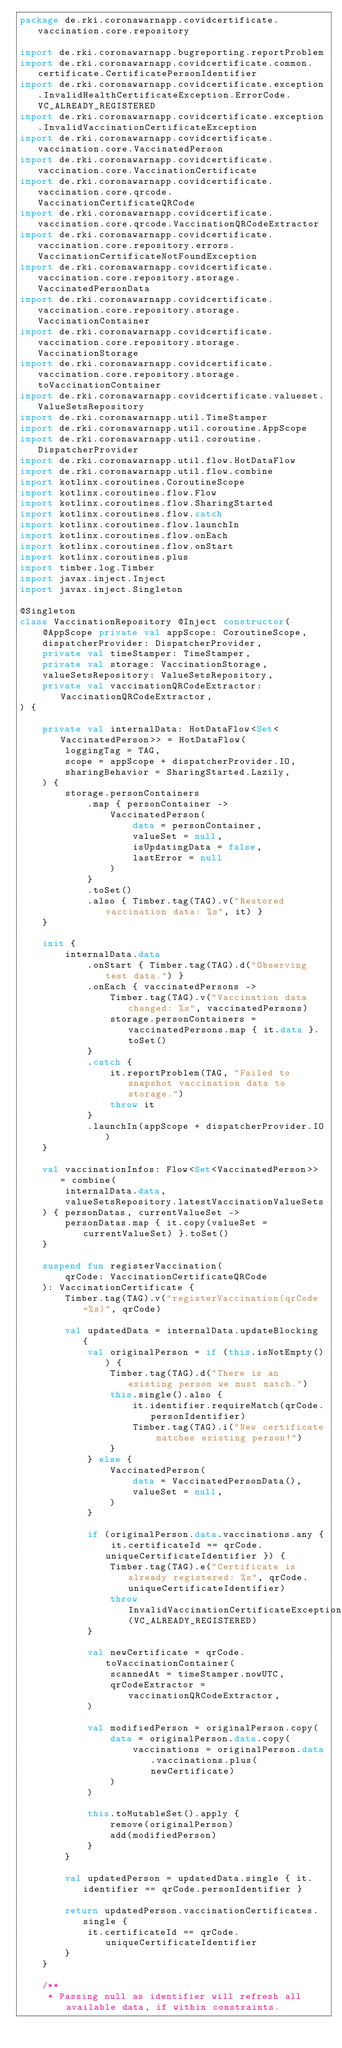Convert code to text. <code><loc_0><loc_0><loc_500><loc_500><_Kotlin_>package de.rki.coronawarnapp.covidcertificate.vaccination.core.repository

import de.rki.coronawarnapp.bugreporting.reportProblem
import de.rki.coronawarnapp.covidcertificate.common.certificate.CertificatePersonIdentifier
import de.rki.coronawarnapp.covidcertificate.exception.InvalidHealthCertificateException.ErrorCode.VC_ALREADY_REGISTERED
import de.rki.coronawarnapp.covidcertificate.exception.InvalidVaccinationCertificateException
import de.rki.coronawarnapp.covidcertificate.vaccination.core.VaccinatedPerson
import de.rki.coronawarnapp.covidcertificate.vaccination.core.VaccinationCertificate
import de.rki.coronawarnapp.covidcertificate.vaccination.core.qrcode.VaccinationCertificateQRCode
import de.rki.coronawarnapp.covidcertificate.vaccination.core.qrcode.VaccinationQRCodeExtractor
import de.rki.coronawarnapp.covidcertificate.vaccination.core.repository.errors.VaccinationCertificateNotFoundException
import de.rki.coronawarnapp.covidcertificate.vaccination.core.repository.storage.VaccinatedPersonData
import de.rki.coronawarnapp.covidcertificate.vaccination.core.repository.storage.VaccinationContainer
import de.rki.coronawarnapp.covidcertificate.vaccination.core.repository.storage.VaccinationStorage
import de.rki.coronawarnapp.covidcertificate.vaccination.core.repository.storage.toVaccinationContainer
import de.rki.coronawarnapp.covidcertificate.valueset.ValueSetsRepository
import de.rki.coronawarnapp.util.TimeStamper
import de.rki.coronawarnapp.util.coroutine.AppScope
import de.rki.coronawarnapp.util.coroutine.DispatcherProvider
import de.rki.coronawarnapp.util.flow.HotDataFlow
import de.rki.coronawarnapp.util.flow.combine
import kotlinx.coroutines.CoroutineScope
import kotlinx.coroutines.flow.Flow
import kotlinx.coroutines.flow.SharingStarted
import kotlinx.coroutines.flow.catch
import kotlinx.coroutines.flow.launchIn
import kotlinx.coroutines.flow.onEach
import kotlinx.coroutines.flow.onStart
import kotlinx.coroutines.plus
import timber.log.Timber
import javax.inject.Inject
import javax.inject.Singleton

@Singleton
class VaccinationRepository @Inject constructor(
    @AppScope private val appScope: CoroutineScope,
    dispatcherProvider: DispatcherProvider,
    private val timeStamper: TimeStamper,
    private val storage: VaccinationStorage,
    valueSetsRepository: ValueSetsRepository,
    private val vaccinationQRCodeExtractor: VaccinationQRCodeExtractor,
) {

    private val internalData: HotDataFlow<Set<VaccinatedPerson>> = HotDataFlow(
        loggingTag = TAG,
        scope = appScope + dispatcherProvider.IO,
        sharingBehavior = SharingStarted.Lazily,
    ) {
        storage.personContainers
            .map { personContainer ->
                VaccinatedPerson(
                    data = personContainer,
                    valueSet = null,
                    isUpdatingData = false,
                    lastError = null
                )
            }
            .toSet()
            .also { Timber.tag(TAG).v("Restored vaccination data: %s", it) }
    }

    init {
        internalData.data
            .onStart { Timber.tag(TAG).d("Observing test data.") }
            .onEach { vaccinatedPersons ->
                Timber.tag(TAG).v("Vaccination data changed: %s", vaccinatedPersons)
                storage.personContainers = vaccinatedPersons.map { it.data }.toSet()
            }
            .catch {
                it.reportProblem(TAG, "Failed to snapshot vaccination data to storage.")
                throw it
            }
            .launchIn(appScope + dispatcherProvider.IO)
    }

    val vaccinationInfos: Flow<Set<VaccinatedPerson>> = combine(
        internalData.data,
        valueSetsRepository.latestVaccinationValueSets
    ) { personDatas, currentValueSet ->
        personDatas.map { it.copy(valueSet = currentValueSet) }.toSet()
    }

    suspend fun registerVaccination(
        qrCode: VaccinationCertificateQRCode
    ): VaccinationCertificate {
        Timber.tag(TAG).v("registerVaccination(qrCode=%s)", qrCode)

        val updatedData = internalData.updateBlocking {
            val originalPerson = if (this.isNotEmpty()) {
                Timber.tag(TAG).d("There is an existing person we must match.")
                this.single().also {
                    it.identifier.requireMatch(qrCode.personIdentifier)
                    Timber.tag(TAG).i("New certificate matches existing person!")
                }
            } else {
                VaccinatedPerson(
                    data = VaccinatedPersonData(),
                    valueSet = null,
                )
            }

            if (originalPerson.data.vaccinations.any { it.certificateId == qrCode.uniqueCertificateIdentifier }) {
                Timber.tag(TAG).e("Certificate is already registered: %s", qrCode.uniqueCertificateIdentifier)
                throw InvalidVaccinationCertificateException(VC_ALREADY_REGISTERED)
            }

            val newCertificate = qrCode.toVaccinationContainer(
                scannedAt = timeStamper.nowUTC,
                qrCodeExtractor = vaccinationQRCodeExtractor,
            )

            val modifiedPerson = originalPerson.copy(
                data = originalPerson.data.copy(
                    vaccinations = originalPerson.data.vaccinations.plus(newCertificate)
                )
            )

            this.toMutableSet().apply {
                remove(originalPerson)
                add(modifiedPerson)
            }
        }

        val updatedPerson = updatedData.single { it.identifier == qrCode.personIdentifier }

        return updatedPerson.vaccinationCertificates.single {
            it.certificateId == qrCode.uniqueCertificateIdentifier
        }
    }

    /**
     * Passing null as identifier will refresh all available data, if within constraints.</code> 